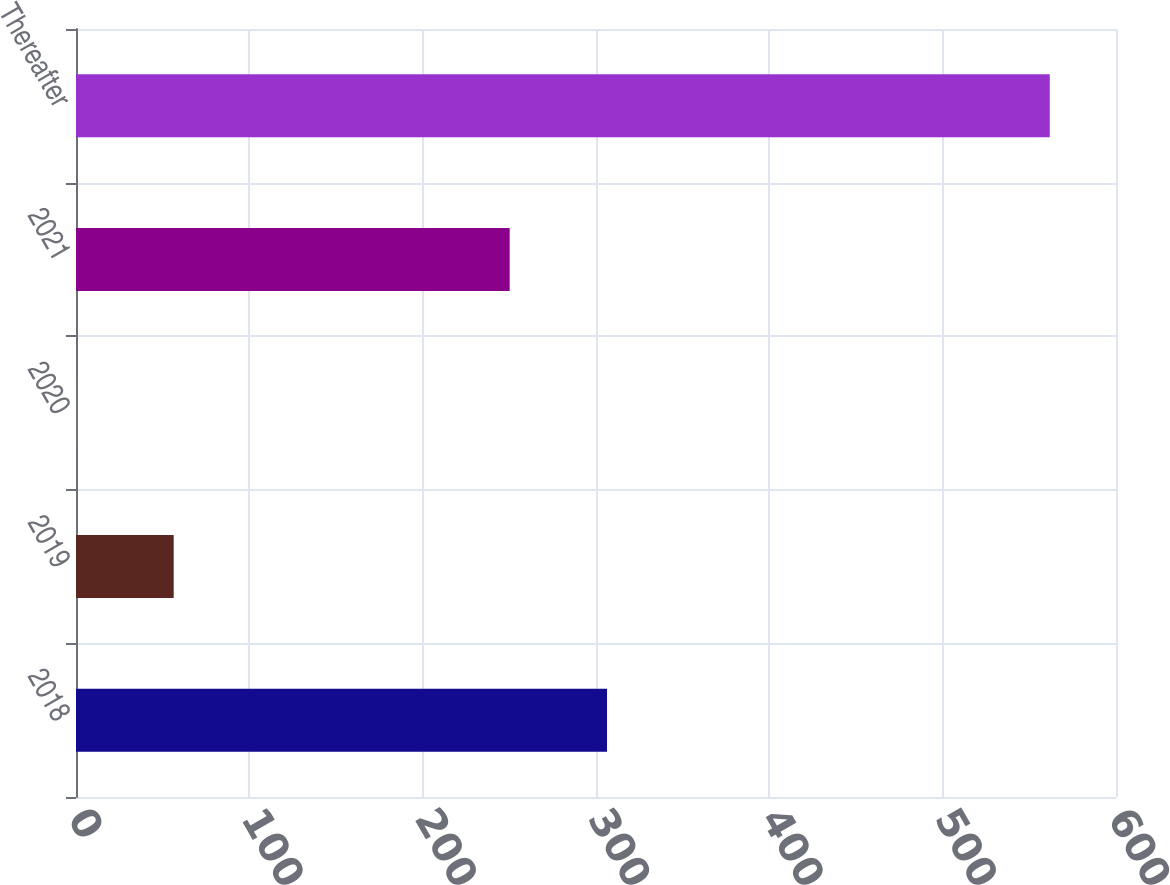Convert chart to OTSL. <chart><loc_0><loc_0><loc_500><loc_500><bar_chart><fcel>2018<fcel>2019<fcel>2020<fcel>2021<fcel>Thereafter<nl><fcel>306.36<fcel>56.36<fcel>0.2<fcel>250.2<fcel>561.8<nl></chart> 